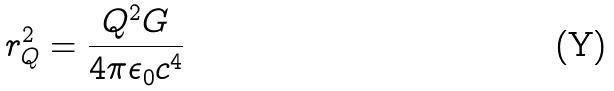Convert formula to latex. <formula><loc_0><loc_0><loc_500><loc_500>r _ { Q } ^ { 2 } = \frac { Q ^ { 2 } G } { 4 \pi \epsilon _ { 0 } c ^ { 4 } }</formula> 